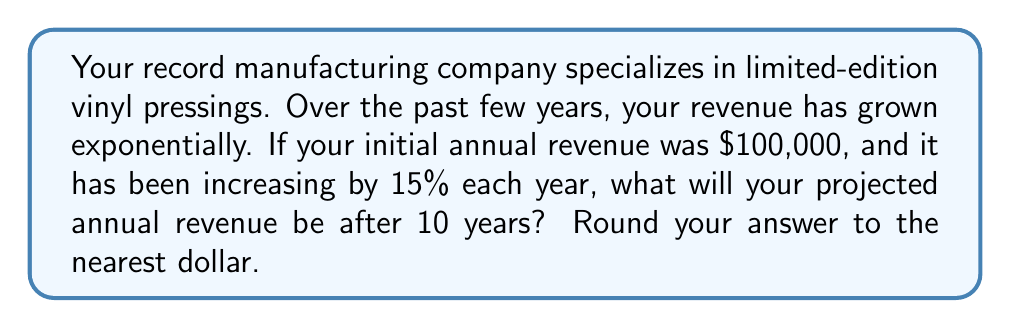What is the answer to this math problem? Let's approach this step-by-step:

1) The initial revenue is $100,000, and it's growing by 15% each year. This is an exponential growth model.

2) The general formula for exponential growth is:
   $$ A = P(1 + r)^t $$
   Where:
   $A$ = final amount
   $P$ = initial principal balance
   $r$ = annual growth rate (in decimal form)
   $t$ = number of years

3) In this case:
   $P = 100,000$
   $r = 15\% = 0.15$
   $t = 10$ years

4) Plugging these values into the formula:
   $$ A = 100,000(1 + 0.15)^{10} $$

5) Simplify inside the parentheses:
   $$ A = 100,000(1.15)^{10} $$

6) Calculate $(1.15)^{10}$:
   $$ (1.15)^{10} \approx 4.0456 $$

7) Multiply:
   $$ A = 100,000 \times 4.0456 = 404,560 $$

8) Rounding to the nearest dollar:
   $$ A = 404,560 $$
Answer: $404,560 